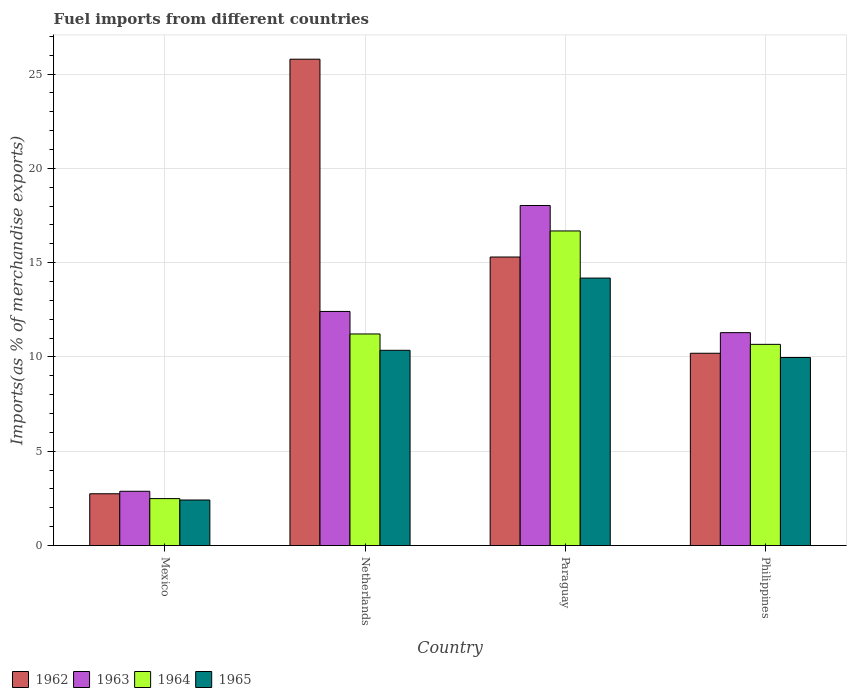Are the number of bars per tick equal to the number of legend labels?
Make the answer very short. Yes. What is the label of the 4th group of bars from the left?
Provide a succinct answer. Philippines. What is the percentage of imports to different countries in 1964 in Netherlands?
Your response must be concise. 11.22. Across all countries, what is the maximum percentage of imports to different countries in 1964?
Keep it short and to the point. 16.68. Across all countries, what is the minimum percentage of imports to different countries in 1962?
Provide a short and direct response. 2.75. In which country was the percentage of imports to different countries in 1965 maximum?
Make the answer very short. Paraguay. In which country was the percentage of imports to different countries in 1964 minimum?
Your answer should be compact. Mexico. What is the total percentage of imports to different countries in 1964 in the graph?
Offer a terse response. 41.06. What is the difference between the percentage of imports to different countries in 1965 in Paraguay and that in Philippines?
Your answer should be compact. 4.21. What is the difference between the percentage of imports to different countries in 1964 in Mexico and the percentage of imports to different countries in 1962 in Netherlands?
Provide a short and direct response. -23.3. What is the average percentage of imports to different countries in 1963 per country?
Ensure brevity in your answer.  11.15. What is the difference between the percentage of imports to different countries of/in 1963 and percentage of imports to different countries of/in 1964 in Philippines?
Offer a terse response. 0.62. In how many countries, is the percentage of imports to different countries in 1962 greater than 10 %?
Keep it short and to the point. 3. What is the ratio of the percentage of imports to different countries in 1965 in Paraguay to that in Philippines?
Keep it short and to the point. 1.42. Is the percentage of imports to different countries in 1962 in Mexico less than that in Philippines?
Keep it short and to the point. Yes. Is the difference between the percentage of imports to different countries in 1963 in Mexico and Netherlands greater than the difference between the percentage of imports to different countries in 1964 in Mexico and Netherlands?
Give a very brief answer. No. What is the difference between the highest and the second highest percentage of imports to different countries in 1962?
Keep it short and to the point. 15.59. What is the difference between the highest and the lowest percentage of imports to different countries in 1963?
Offer a terse response. 15.15. In how many countries, is the percentage of imports to different countries in 1962 greater than the average percentage of imports to different countries in 1962 taken over all countries?
Your answer should be very brief. 2. Is it the case that in every country, the sum of the percentage of imports to different countries in 1965 and percentage of imports to different countries in 1963 is greater than the sum of percentage of imports to different countries in 1964 and percentage of imports to different countries in 1962?
Provide a succinct answer. No. What does the 2nd bar from the right in Philippines represents?
Ensure brevity in your answer.  1964. Is it the case that in every country, the sum of the percentage of imports to different countries in 1962 and percentage of imports to different countries in 1964 is greater than the percentage of imports to different countries in 1963?
Offer a very short reply. Yes. How many bars are there?
Your answer should be compact. 16. Are all the bars in the graph horizontal?
Give a very brief answer. No. How many countries are there in the graph?
Keep it short and to the point. 4. What is the difference between two consecutive major ticks on the Y-axis?
Provide a short and direct response. 5. Does the graph contain any zero values?
Offer a terse response. No. Does the graph contain grids?
Give a very brief answer. Yes. How are the legend labels stacked?
Give a very brief answer. Horizontal. What is the title of the graph?
Provide a short and direct response. Fuel imports from different countries. Does "1992" appear as one of the legend labels in the graph?
Your answer should be compact. No. What is the label or title of the Y-axis?
Your answer should be very brief. Imports(as % of merchandise exports). What is the Imports(as % of merchandise exports) of 1962 in Mexico?
Your response must be concise. 2.75. What is the Imports(as % of merchandise exports) of 1963 in Mexico?
Provide a succinct answer. 2.88. What is the Imports(as % of merchandise exports) in 1964 in Mexico?
Your answer should be compact. 2.49. What is the Imports(as % of merchandise exports) of 1965 in Mexico?
Make the answer very short. 2.42. What is the Imports(as % of merchandise exports) in 1962 in Netherlands?
Your answer should be compact. 25.79. What is the Imports(as % of merchandise exports) in 1963 in Netherlands?
Keep it short and to the point. 12.41. What is the Imports(as % of merchandise exports) in 1964 in Netherlands?
Your answer should be very brief. 11.22. What is the Imports(as % of merchandise exports) of 1965 in Netherlands?
Ensure brevity in your answer.  10.35. What is the Imports(as % of merchandise exports) in 1962 in Paraguay?
Provide a short and direct response. 15.3. What is the Imports(as % of merchandise exports) in 1963 in Paraguay?
Provide a short and direct response. 18.03. What is the Imports(as % of merchandise exports) of 1964 in Paraguay?
Make the answer very short. 16.68. What is the Imports(as % of merchandise exports) of 1965 in Paraguay?
Provide a succinct answer. 14.18. What is the Imports(as % of merchandise exports) of 1962 in Philippines?
Ensure brevity in your answer.  10.2. What is the Imports(as % of merchandise exports) of 1963 in Philippines?
Offer a very short reply. 11.29. What is the Imports(as % of merchandise exports) in 1964 in Philippines?
Your response must be concise. 10.67. What is the Imports(as % of merchandise exports) in 1965 in Philippines?
Ensure brevity in your answer.  9.97. Across all countries, what is the maximum Imports(as % of merchandise exports) in 1962?
Offer a terse response. 25.79. Across all countries, what is the maximum Imports(as % of merchandise exports) of 1963?
Ensure brevity in your answer.  18.03. Across all countries, what is the maximum Imports(as % of merchandise exports) in 1964?
Your response must be concise. 16.68. Across all countries, what is the maximum Imports(as % of merchandise exports) of 1965?
Your answer should be very brief. 14.18. Across all countries, what is the minimum Imports(as % of merchandise exports) of 1962?
Provide a succinct answer. 2.75. Across all countries, what is the minimum Imports(as % of merchandise exports) in 1963?
Offer a very short reply. 2.88. Across all countries, what is the minimum Imports(as % of merchandise exports) in 1964?
Your response must be concise. 2.49. Across all countries, what is the minimum Imports(as % of merchandise exports) of 1965?
Your response must be concise. 2.42. What is the total Imports(as % of merchandise exports) in 1962 in the graph?
Offer a terse response. 54.03. What is the total Imports(as % of merchandise exports) of 1963 in the graph?
Your answer should be very brief. 44.61. What is the total Imports(as % of merchandise exports) of 1964 in the graph?
Your response must be concise. 41.06. What is the total Imports(as % of merchandise exports) of 1965 in the graph?
Your answer should be very brief. 36.92. What is the difference between the Imports(as % of merchandise exports) in 1962 in Mexico and that in Netherlands?
Give a very brief answer. -23.04. What is the difference between the Imports(as % of merchandise exports) in 1963 in Mexico and that in Netherlands?
Offer a terse response. -9.53. What is the difference between the Imports(as % of merchandise exports) of 1964 in Mexico and that in Netherlands?
Provide a succinct answer. -8.73. What is the difference between the Imports(as % of merchandise exports) in 1965 in Mexico and that in Netherlands?
Keep it short and to the point. -7.94. What is the difference between the Imports(as % of merchandise exports) in 1962 in Mexico and that in Paraguay?
Your answer should be very brief. -12.55. What is the difference between the Imports(as % of merchandise exports) of 1963 in Mexico and that in Paraguay?
Your answer should be very brief. -15.15. What is the difference between the Imports(as % of merchandise exports) of 1964 in Mexico and that in Paraguay?
Make the answer very short. -14.19. What is the difference between the Imports(as % of merchandise exports) in 1965 in Mexico and that in Paraguay?
Your answer should be compact. -11.77. What is the difference between the Imports(as % of merchandise exports) in 1962 in Mexico and that in Philippines?
Make the answer very short. -7.45. What is the difference between the Imports(as % of merchandise exports) of 1963 in Mexico and that in Philippines?
Your response must be concise. -8.41. What is the difference between the Imports(as % of merchandise exports) in 1964 in Mexico and that in Philippines?
Keep it short and to the point. -8.18. What is the difference between the Imports(as % of merchandise exports) in 1965 in Mexico and that in Philippines?
Offer a terse response. -7.55. What is the difference between the Imports(as % of merchandise exports) in 1962 in Netherlands and that in Paraguay?
Keep it short and to the point. 10.49. What is the difference between the Imports(as % of merchandise exports) of 1963 in Netherlands and that in Paraguay?
Keep it short and to the point. -5.62. What is the difference between the Imports(as % of merchandise exports) in 1964 in Netherlands and that in Paraguay?
Keep it short and to the point. -5.46. What is the difference between the Imports(as % of merchandise exports) of 1965 in Netherlands and that in Paraguay?
Your response must be concise. -3.83. What is the difference between the Imports(as % of merchandise exports) in 1962 in Netherlands and that in Philippines?
Your response must be concise. 15.59. What is the difference between the Imports(as % of merchandise exports) of 1963 in Netherlands and that in Philippines?
Provide a succinct answer. 1.12. What is the difference between the Imports(as % of merchandise exports) in 1964 in Netherlands and that in Philippines?
Provide a short and direct response. 0.55. What is the difference between the Imports(as % of merchandise exports) in 1965 in Netherlands and that in Philippines?
Your answer should be very brief. 0.38. What is the difference between the Imports(as % of merchandise exports) of 1962 in Paraguay and that in Philippines?
Your answer should be very brief. 5.1. What is the difference between the Imports(as % of merchandise exports) of 1963 in Paraguay and that in Philippines?
Your response must be concise. 6.74. What is the difference between the Imports(as % of merchandise exports) of 1964 in Paraguay and that in Philippines?
Offer a very short reply. 6.01. What is the difference between the Imports(as % of merchandise exports) in 1965 in Paraguay and that in Philippines?
Offer a very short reply. 4.21. What is the difference between the Imports(as % of merchandise exports) of 1962 in Mexico and the Imports(as % of merchandise exports) of 1963 in Netherlands?
Offer a very short reply. -9.67. What is the difference between the Imports(as % of merchandise exports) of 1962 in Mexico and the Imports(as % of merchandise exports) of 1964 in Netherlands?
Provide a succinct answer. -8.47. What is the difference between the Imports(as % of merchandise exports) in 1962 in Mexico and the Imports(as % of merchandise exports) in 1965 in Netherlands?
Your answer should be compact. -7.61. What is the difference between the Imports(as % of merchandise exports) in 1963 in Mexico and the Imports(as % of merchandise exports) in 1964 in Netherlands?
Provide a succinct answer. -8.34. What is the difference between the Imports(as % of merchandise exports) of 1963 in Mexico and the Imports(as % of merchandise exports) of 1965 in Netherlands?
Keep it short and to the point. -7.47. What is the difference between the Imports(as % of merchandise exports) in 1964 in Mexico and the Imports(as % of merchandise exports) in 1965 in Netherlands?
Your response must be concise. -7.86. What is the difference between the Imports(as % of merchandise exports) of 1962 in Mexico and the Imports(as % of merchandise exports) of 1963 in Paraguay?
Your response must be concise. -15.28. What is the difference between the Imports(as % of merchandise exports) in 1962 in Mexico and the Imports(as % of merchandise exports) in 1964 in Paraguay?
Your answer should be compact. -13.93. What is the difference between the Imports(as % of merchandise exports) in 1962 in Mexico and the Imports(as % of merchandise exports) in 1965 in Paraguay?
Provide a succinct answer. -11.44. What is the difference between the Imports(as % of merchandise exports) of 1963 in Mexico and the Imports(as % of merchandise exports) of 1964 in Paraguay?
Make the answer very short. -13.8. What is the difference between the Imports(as % of merchandise exports) of 1963 in Mexico and the Imports(as % of merchandise exports) of 1965 in Paraguay?
Provide a short and direct response. -11.3. What is the difference between the Imports(as % of merchandise exports) in 1964 in Mexico and the Imports(as % of merchandise exports) in 1965 in Paraguay?
Your answer should be compact. -11.69. What is the difference between the Imports(as % of merchandise exports) in 1962 in Mexico and the Imports(as % of merchandise exports) in 1963 in Philippines?
Your response must be concise. -8.54. What is the difference between the Imports(as % of merchandise exports) in 1962 in Mexico and the Imports(as % of merchandise exports) in 1964 in Philippines?
Keep it short and to the point. -7.92. What is the difference between the Imports(as % of merchandise exports) in 1962 in Mexico and the Imports(as % of merchandise exports) in 1965 in Philippines?
Ensure brevity in your answer.  -7.22. What is the difference between the Imports(as % of merchandise exports) in 1963 in Mexico and the Imports(as % of merchandise exports) in 1964 in Philippines?
Your response must be concise. -7.79. What is the difference between the Imports(as % of merchandise exports) of 1963 in Mexico and the Imports(as % of merchandise exports) of 1965 in Philippines?
Provide a succinct answer. -7.09. What is the difference between the Imports(as % of merchandise exports) in 1964 in Mexico and the Imports(as % of merchandise exports) in 1965 in Philippines?
Offer a terse response. -7.48. What is the difference between the Imports(as % of merchandise exports) in 1962 in Netherlands and the Imports(as % of merchandise exports) in 1963 in Paraguay?
Provide a succinct answer. 7.76. What is the difference between the Imports(as % of merchandise exports) of 1962 in Netherlands and the Imports(as % of merchandise exports) of 1964 in Paraguay?
Make the answer very short. 9.11. What is the difference between the Imports(as % of merchandise exports) in 1962 in Netherlands and the Imports(as % of merchandise exports) in 1965 in Paraguay?
Make the answer very short. 11.6. What is the difference between the Imports(as % of merchandise exports) in 1963 in Netherlands and the Imports(as % of merchandise exports) in 1964 in Paraguay?
Provide a succinct answer. -4.27. What is the difference between the Imports(as % of merchandise exports) of 1963 in Netherlands and the Imports(as % of merchandise exports) of 1965 in Paraguay?
Offer a very short reply. -1.77. What is the difference between the Imports(as % of merchandise exports) in 1964 in Netherlands and the Imports(as % of merchandise exports) in 1965 in Paraguay?
Provide a short and direct response. -2.96. What is the difference between the Imports(as % of merchandise exports) of 1962 in Netherlands and the Imports(as % of merchandise exports) of 1963 in Philippines?
Make the answer very short. 14.5. What is the difference between the Imports(as % of merchandise exports) of 1962 in Netherlands and the Imports(as % of merchandise exports) of 1964 in Philippines?
Your response must be concise. 15.12. What is the difference between the Imports(as % of merchandise exports) of 1962 in Netherlands and the Imports(as % of merchandise exports) of 1965 in Philippines?
Your response must be concise. 15.82. What is the difference between the Imports(as % of merchandise exports) of 1963 in Netherlands and the Imports(as % of merchandise exports) of 1964 in Philippines?
Offer a very short reply. 1.74. What is the difference between the Imports(as % of merchandise exports) of 1963 in Netherlands and the Imports(as % of merchandise exports) of 1965 in Philippines?
Your answer should be very brief. 2.44. What is the difference between the Imports(as % of merchandise exports) of 1964 in Netherlands and the Imports(as % of merchandise exports) of 1965 in Philippines?
Your answer should be compact. 1.25. What is the difference between the Imports(as % of merchandise exports) in 1962 in Paraguay and the Imports(as % of merchandise exports) in 1963 in Philippines?
Give a very brief answer. 4.01. What is the difference between the Imports(as % of merchandise exports) of 1962 in Paraguay and the Imports(as % of merchandise exports) of 1964 in Philippines?
Offer a terse response. 4.63. What is the difference between the Imports(as % of merchandise exports) of 1962 in Paraguay and the Imports(as % of merchandise exports) of 1965 in Philippines?
Offer a terse response. 5.33. What is the difference between the Imports(as % of merchandise exports) in 1963 in Paraguay and the Imports(as % of merchandise exports) in 1964 in Philippines?
Your answer should be compact. 7.36. What is the difference between the Imports(as % of merchandise exports) in 1963 in Paraguay and the Imports(as % of merchandise exports) in 1965 in Philippines?
Give a very brief answer. 8.06. What is the difference between the Imports(as % of merchandise exports) in 1964 in Paraguay and the Imports(as % of merchandise exports) in 1965 in Philippines?
Keep it short and to the point. 6.71. What is the average Imports(as % of merchandise exports) in 1962 per country?
Ensure brevity in your answer.  13.51. What is the average Imports(as % of merchandise exports) in 1963 per country?
Your response must be concise. 11.15. What is the average Imports(as % of merchandise exports) in 1964 per country?
Ensure brevity in your answer.  10.26. What is the average Imports(as % of merchandise exports) in 1965 per country?
Your answer should be compact. 9.23. What is the difference between the Imports(as % of merchandise exports) of 1962 and Imports(as % of merchandise exports) of 1963 in Mexico?
Make the answer very short. -0.13. What is the difference between the Imports(as % of merchandise exports) in 1962 and Imports(as % of merchandise exports) in 1964 in Mexico?
Make the answer very short. 0.26. What is the difference between the Imports(as % of merchandise exports) of 1962 and Imports(as % of merchandise exports) of 1965 in Mexico?
Your answer should be compact. 0.33. What is the difference between the Imports(as % of merchandise exports) of 1963 and Imports(as % of merchandise exports) of 1964 in Mexico?
Your answer should be compact. 0.39. What is the difference between the Imports(as % of merchandise exports) of 1963 and Imports(as % of merchandise exports) of 1965 in Mexico?
Provide a short and direct response. 0.46. What is the difference between the Imports(as % of merchandise exports) in 1964 and Imports(as % of merchandise exports) in 1965 in Mexico?
Ensure brevity in your answer.  0.07. What is the difference between the Imports(as % of merchandise exports) of 1962 and Imports(as % of merchandise exports) of 1963 in Netherlands?
Ensure brevity in your answer.  13.37. What is the difference between the Imports(as % of merchandise exports) of 1962 and Imports(as % of merchandise exports) of 1964 in Netherlands?
Your answer should be compact. 14.57. What is the difference between the Imports(as % of merchandise exports) in 1962 and Imports(as % of merchandise exports) in 1965 in Netherlands?
Ensure brevity in your answer.  15.43. What is the difference between the Imports(as % of merchandise exports) of 1963 and Imports(as % of merchandise exports) of 1964 in Netherlands?
Offer a terse response. 1.19. What is the difference between the Imports(as % of merchandise exports) in 1963 and Imports(as % of merchandise exports) in 1965 in Netherlands?
Provide a short and direct response. 2.06. What is the difference between the Imports(as % of merchandise exports) in 1964 and Imports(as % of merchandise exports) in 1965 in Netherlands?
Your answer should be compact. 0.87. What is the difference between the Imports(as % of merchandise exports) in 1962 and Imports(as % of merchandise exports) in 1963 in Paraguay?
Keep it short and to the point. -2.73. What is the difference between the Imports(as % of merchandise exports) of 1962 and Imports(as % of merchandise exports) of 1964 in Paraguay?
Offer a terse response. -1.38. What is the difference between the Imports(as % of merchandise exports) in 1962 and Imports(as % of merchandise exports) in 1965 in Paraguay?
Your response must be concise. 1.12. What is the difference between the Imports(as % of merchandise exports) in 1963 and Imports(as % of merchandise exports) in 1964 in Paraguay?
Your answer should be very brief. 1.35. What is the difference between the Imports(as % of merchandise exports) in 1963 and Imports(as % of merchandise exports) in 1965 in Paraguay?
Provide a short and direct response. 3.85. What is the difference between the Imports(as % of merchandise exports) in 1964 and Imports(as % of merchandise exports) in 1965 in Paraguay?
Give a very brief answer. 2.5. What is the difference between the Imports(as % of merchandise exports) of 1962 and Imports(as % of merchandise exports) of 1963 in Philippines?
Keep it short and to the point. -1.09. What is the difference between the Imports(as % of merchandise exports) of 1962 and Imports(as % of merchandise exports) of 1964 in Philippines?
Keep it short and to the point. -0.47. What is the difference between the Imports(as % of merchandise exports) of 1962 and Imports(as % of merchandise exports) of 1965 in Philippines?
Keep it short and to the point. 0.23. What is the difference between the Imports(as % of merchandise exports) of 1963 and Imports(as % of merchandise exports) of 1964 in Philippines?
Give a very brief answer. 0.62. What is the difference between the Imports(as % of merchandise exports) of 1963 and Imports(as % of merchandise exports) of 1965 in Philippines?
Offer a very short reply. 1.32. What is the difference between the Imports(as % of merchandise exports) of 1964 and Imports(as % of merchandise exports) of 1965 in Philippines?
Provide a succinct answer. 0.7. What is the ratio of the Imports(as % of merchandise exports) in 1962 in Mexico to that in Netherlands?
Offer a terse response. 0.11. What is the ratio of the Imports(as % of merchandise exports) in 1963 in Mexico to that in Netherlands?
Your answer should be compact. 0.23. What is the ratio of the Imports(as % of merchandise exports) of 1964 in Mexico to that in Netherlands?
Provide a short and direct response. 0.22. What is the ratio of the Imports(as % of merchandise exports) in 1965 in Mexico to that in Netherlands?
Offer a very short reply. 0.23. What is the ratio of the Imports(as % of merchandise exports) in 1962 in Mexico to that in Paraguay?
Keep it short and to the point. 0.18. What is the ratio of the Imports(as % of merchandise exports) of 1963 in Mexico to that in Paraguay?
Provide a short and direct response. 0.16. What is the ratio of the Imports(as % of merchandise exports) of 1964 in Mexico to that in Paraguay?
Provide a short and direct response. 0.15. What is the ratio of the Imports(as % of merchandise exports) in 1965 in Mexico to that in Paraguay?
Offer a very short reply. 0.17. What is the ratio of the Imports(as % of merchandise exports) in 1962 in Mexico to that in Philippines?
Your answer should be compact. 0.27. What is the ratio of the Imports(as % of merchandise exports) of 1963 in Mexico to that in Philippines?
Make the answer very short. 0.26. What is the ratio of the Imports(as % of merchandise exports) of 1964 in Mexico to that in Philippines?
Your answer should be compact. 0.23. What is the ratio of the Imports(as % of merchandise exports) in 1965 in Mexico to that in Philippines?
Give a very brief answer. 0.24. What is the ratio of the Imports(as % of merchandise exports) in 1962 in Netherlands to that in Paraguay?
Keep it short and to the point. 1.69. What is the ratio of the Imports(as % of merchandise exports) of 1963 in Netherlands to that in Paraguay?
Your answer should be very brief. 0.69. What is the ratio of the Imports(as % of merchandise exports) in 1964 in Netherlands to that in Paraguay?
Your answer should be compact. 0.67. What is the ratio of the Imports(as % of merchandise exports) in 1965 in Netherlands to that in Paraguay?
Give a very brief answer. 0.73. What is the ratio of the Imports(as % of merchandise exports) of 1962 in Netherlands to that in Philippines?
Offer a terse response. 2.53. What is the ratio of the Imports(as % of merchandise exports) in 1963 in Netherlands to that in Philippines?
Provide a short and direct response. 1.1. What is the ratio of the Imports(as % of merchandise exports) of 1964 in Netherlands to that in Philippines?
Keep it short and to the point. 1.05. What is the ratio of the Imports(as % of merchandise exports) in 1965 in Netherlands to that in Philippines?
Offer a very short reply. 1.04. What is the ratio of the Imports(as % of merchandise exports) in 1962 in Paraguay to that in Philippines?
Your response must be concise. 1.5. What is the ratio of the Imports(as % of merchandise exports) in 1963 in Paraguay to that in Philippines?
Your answer should be compact. 1.6. What is the ratio of the Imports(as % of merchandise exports) in 1964 in Paraguay to that in Philippines?
Your answer should be very brief. 1.56. What is the ratio of the Imports(as % of merchandise exports) in 1965 in Paraguay to that in Philippines?
Give a very brief answer. 1.42. What is the difference between the highest and the second highest Imports(as % of merchandise exports) of 1962?
Give a very brief answer. 10.49. What is the difference between the highest and the second highest Imports(as % of merchandise exports) in 1963?
Provide a succinct answer. 5.62. What is the difference between the highest and the second highest Imports(as % of merchandise exports) in 1964?
Your answer should be very brief. 5.46. What is the difference between the highest and the second highest Imports(as % of merchandise exports) in 1965?
Give a very brief answer. 3.83. What is the difference between the highest and the lowest Imports(as % of merchandise exports) in 1962?
Ensure brevity in your answer.  23.04. What is the difference between the highest and the lowest Imports(as % of merchandise exports) in 1963?
Your response must be concise. 15.15. What is the difference between the highest and the lowest Imports(as % of merchandise exports) of 1964?
Provide a succinct answer. 14.19. What is the difference between the highest and the lowest Imports(as % of merchandise exports) in 1965?
Ensure brevity in your answer.  11.77. 